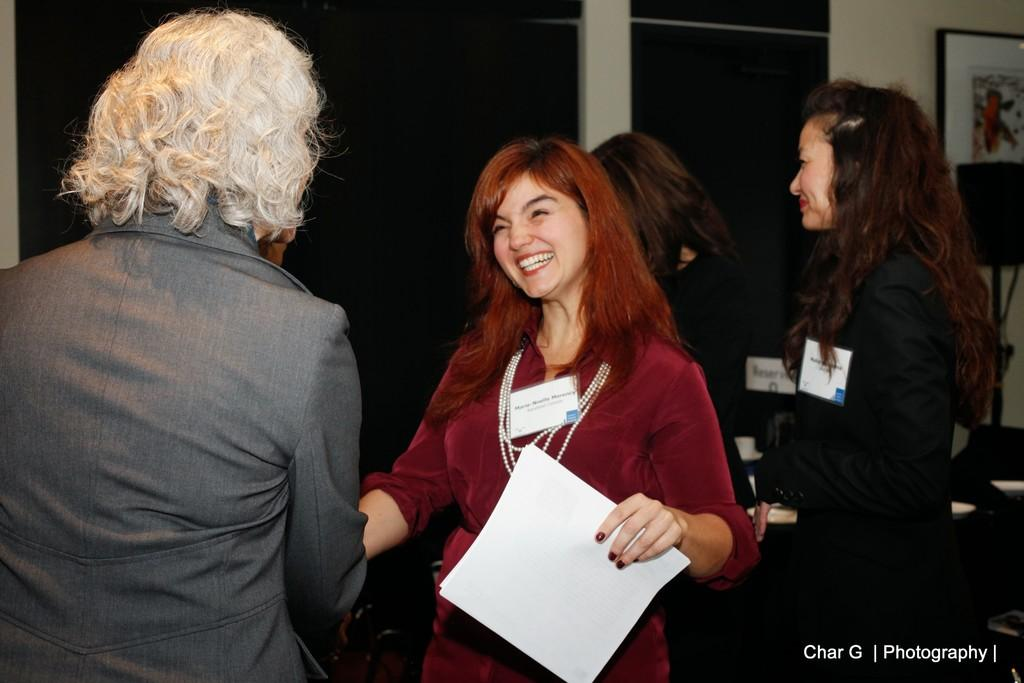How many people are in the image? There are four persons in the image. What is the lady holding in the image? The lady is holding a paper in the image. Can you describe something on the wall in the image? There is a photo frame on the wall in the image. What can be seen on the right side of the image? There are objects on the right side of the image. What type of toy can be seen in the wilderness in the image? There is no toy or wilderness present in the image. 